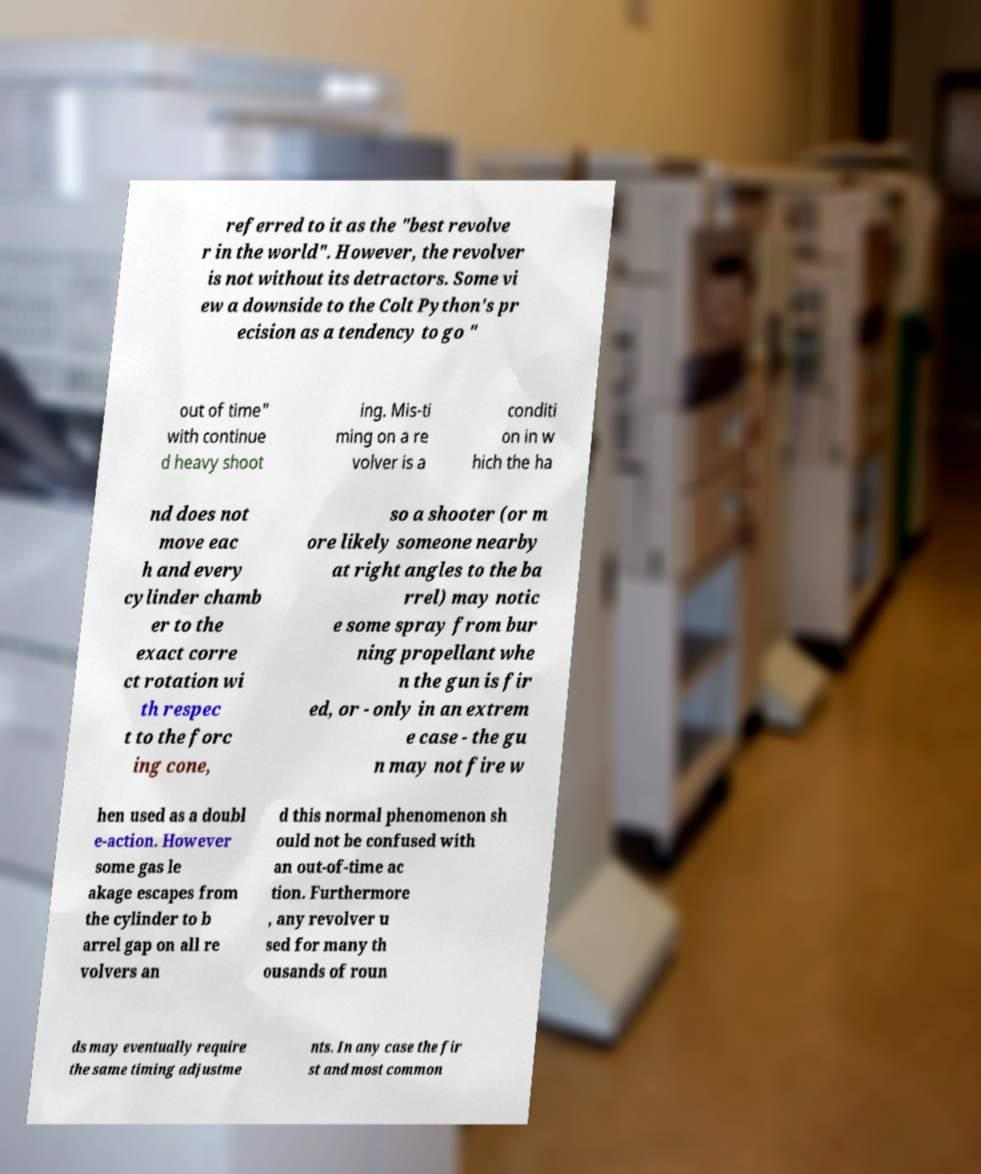Could you extract and type out the text from this image? referred to it as the "best revolve r in the world". However, the revolver is not without its detractors. Some vi ew a downside to the Colt Python's pr ecision as a tendency to go " out of time" with continue d heavy shoot ing. Mis-ti ming on a re volver is a conditi on in w hich the ha nd does not move eac h and every cylinder chamb er to the exact corre ct rotation wi th respec t to the forc ing cone, so a shooter (or m ore likely someone nearby at right angles to the ba rrel) may notic e some spray from bur ning propellant whe n the gun is fir ed, or - only in an extrem e case - the gu n may not fire w hen used as a doubl e-action. However some gas le akage escapes from the cylinder to b arrel gap on all re volvers an d this normal phenomenon sh ould not be confused with an out-of-time ac tion. Furthermore , any revolver u sed for many th ousands of roun ds may eventually require the same timing adjustme nts. In any case the fir st and most common 